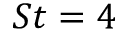Convert formula to latex. <formula><loc_0><loc_0><loc_500><loc_500>S t = 4</formula> 